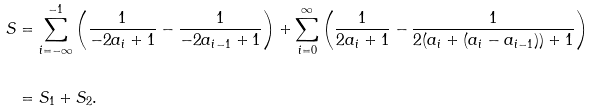Convert formula to latex. <formula><loc_0><loc_0><loc_500><loc_500>S & = \sum _ { i = - \infty } ^ { - 1 } \left ( \frac { 1 } { - 2 a _ { i } + 1 } - \frac { 1 } { - 2 a _ { i - 1 } + 1 } \right ) + \sum _ { i = 0 } ^ { \infty } \left ( \frac { 1 } { 2 a _ { i } + 1 } - \frac { 1 } { 2 ( a _ { i } + ( a _ { i } - a _ { i - 1 } ) ) + 1 } \right ) \\ \\ & = S _ { 1 } + S _ { 2 } .</formula> 